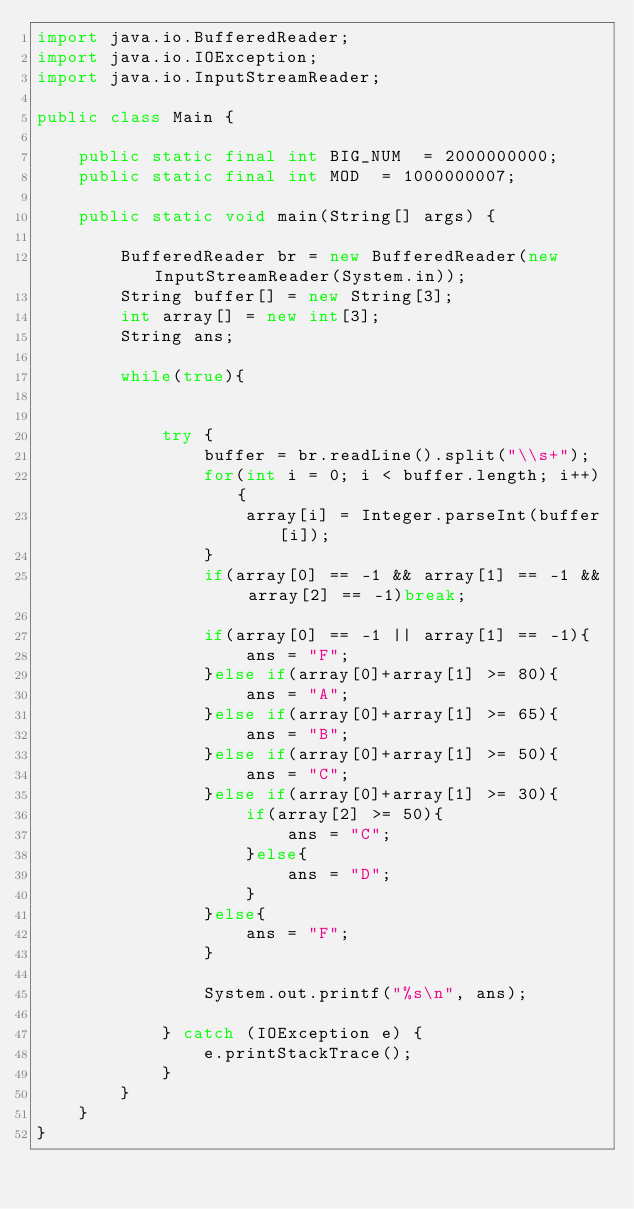Convert code to text. <code><loc_0><loc_0><loc_500><loc_500><_Java_>import java.io.BufferedReader;
import java.io.IOException;
import java.io.InputStreamReader;
 
public class Main {
 
    public static final int BIG_NUM  = 2000000000;
    public static final int MOD  = 1000000007;
 
    public static void main(String[] args) {
 
        BufferedReader br = new BufferedReader(new InputStreamReader(System.in));
        String buffer[] = new String[3];
        int array[] = new int[3];
        String ans;
 
        while(true){
 
 
            try {
                buffer = br.readLine().split("\\s+");
                for(int i = 0; i < buffer.length; i++){
                    array[i] = Integer.parseInt(buffer[i]);
                }
                if(array[0] == -1 && array[1] == -1 && array[2] == -1)break;
 
                if(array[0] == -1 || array[1] == -1){
                    ans = "F";
                }else if(array[0]+array[1] >= 80){
                    ans = "A";
                }else if(array[0]+array[1] >= 65){
                    ans = "B";
                }else if(array[0]+array[1] >= 50){
                    ans = "C";
                }else if(array[0]+array[1] >= 30){
                    if(array[2] >= 50){
                        ans = "C";
                    }else{
                        ans = "D";
                    }
                }else{
                    ans = "F";
                }
 
                System.out.printf("%s\n", ans);
 
            } catch (IOException e) {
                e.printStackTrace();
            }
        }
    }
}
</code> 